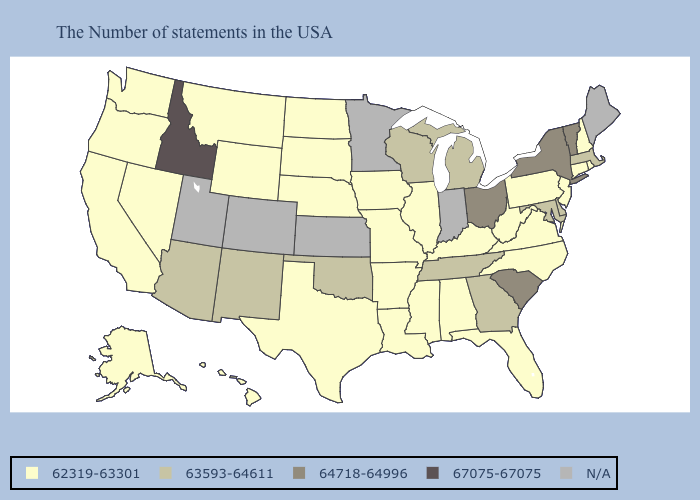Name the states that have a value in the range 64718-64996?
Write a very short answer. Vermont, New York, South Carolina, Ohio. Among the states that border South Carolina , does North Carolina have the lowest value?
Concise answer only. Yes. Which states hav the highest value in the MidWest?
Write a very short answer. Ohio. Does Rhode Island have the lowest value in the USA?
Be succinct. Yes. Name the states that have a value in the range 63593-64611?
Concise answer only. Massachusetts, Delaware, Maryland, Georgia, Michigan, Tennessee, Wisconsin, Oklahoma, New Mexico, Arizona. What is the value of Delaware?
Be succinct. 63593-64611. What is the value of California?
Write a very short answer. 62319-63301. Which states hav the highest value in the South?
Quick response, please. South Carolina. Name the states that have a value in the range N/A?
Quick response, please. Maine, Indiana, Minnesota, Kansas, Colorado, Utah. What is the highest value in states that border Nevada?
Answer briefly. 67075-67075. What is the value of Montana?
Concise answer only. 62319-63301. What is the value of New Mexico?
Answer briefly. 63593-64611. What is the value of Oregon?
Be succinct. 62319-63301. What is the highest value in the USA?
Concise answer only. 67075-67075. 